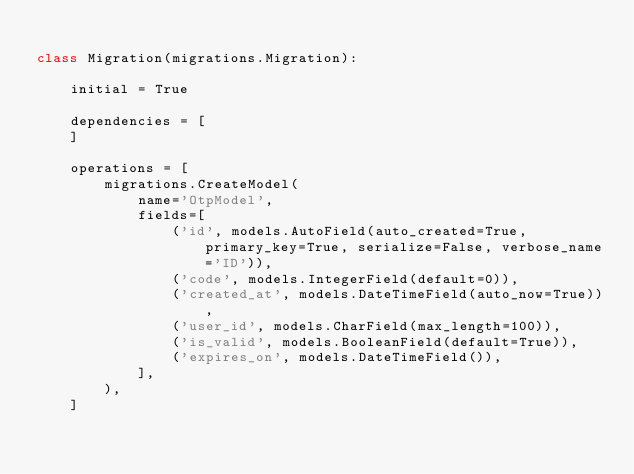Convert code to text. <code><loc_0><loc_0><loc_500><loc_500><_Python_>
class Migration(migrations.Migration):

    initial = True

    dependencies = [
    ]

    operations = [
        migrations.CreateModel(
            name='OtpModel',
            fields=[
                ('id', models.AutoField(auto_created=True, primary_key=True, serialize=False, verbose_name='ID')),
                ('code', models.IntegerField(default=0)),
                ('created_at', models.DateTimeField(auto_now=True)),
                ('user_id', models.CharField(max_length=100)),
                ('is_valid', models.BooleanField(default=True)),
                ('expires_on', models.DateTimeField()),
            ],
        ),
    ]
</code> 